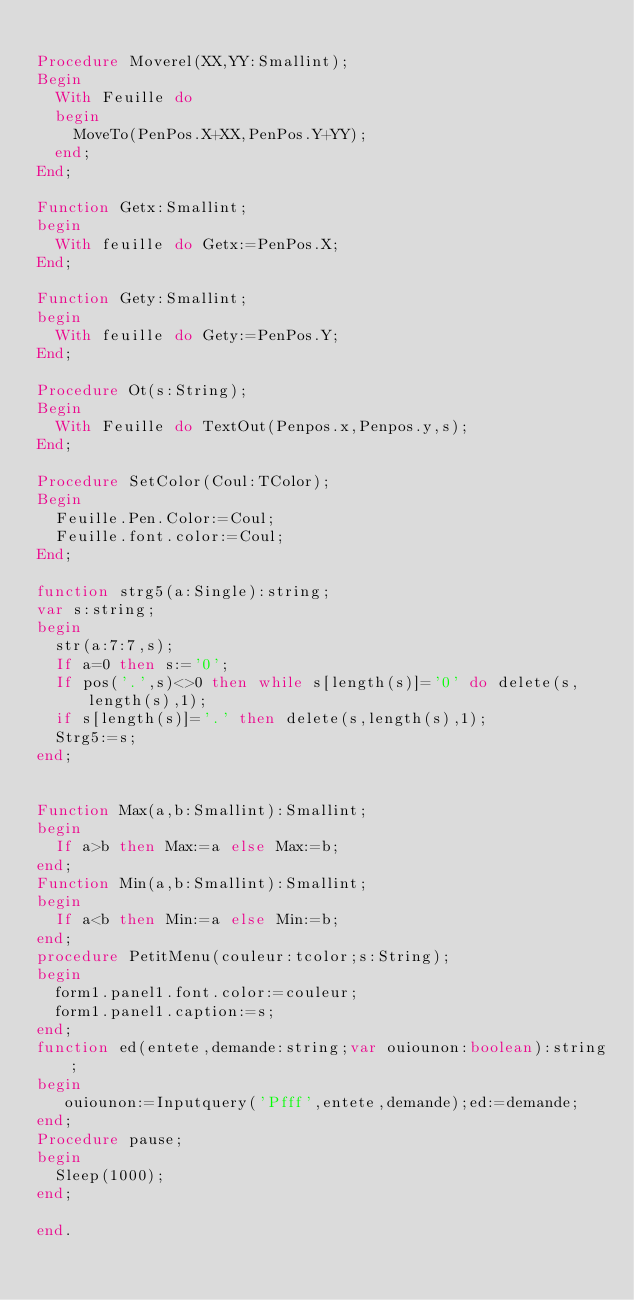Convert code to text. <code><loc_0><loc_0><loc_500><loc_500><_Pascal_>
Procedure Moverel(XX,YY:Smallint);
Begin
  With Feuille do
  begin
    MoveTo(PenPos.X+XX,PenPos.Y+YY);
  end;
End;

Function Getx:Smallint;
begin
  With feuille do Getx:=PenPos.X;
End;

Function Gety:Smallint;
begin
  With feuille do Gety:=PenPos.Y;
End;

Procedure Ot(s:String);
Begin
  With Feuille do TextOut(Penpos.x,Penpos.y,s);
End;

Procedure SetColor(Coul:TColor);
Begin
  Feuille.Pen.Color:=Coul;
  Feuille.font.color:=Coul;
End;

function strg5(a:Single):string;
var s:string;
begin
  str(a:7:7,s);
  If a=0 then s:='0';
  If pos('.',s)<>0 then while s[length(s)]='0' do delete(s,length(s),1);
  if s[length(s)]='.' then delete(s,length(s),1);
  Strg5:=s;
end;


Function Max(a,b:Smallint):Smallint;
begin
  If a>b then Max:=a else Max:=b;
end;
Function Min(a,b:Smallint):Smallint;
begin
  If a<b then Min:=a else Min:=b;
end;
procedure PetitMenu(couleur:tcolor;s:String);
begin
  form1.panel1.font.color:=couleur;
  form1.panel1.caption:=s;
end;
function ed(entete,demande:string;var ouiounon:boolean):string;
begin
   ouiounon:=Inputquery('Pfff',entete,demande);ed:=demande;
end;
Procedure pause;
begin
  Sleep(1000);
end;

end.
</code> 